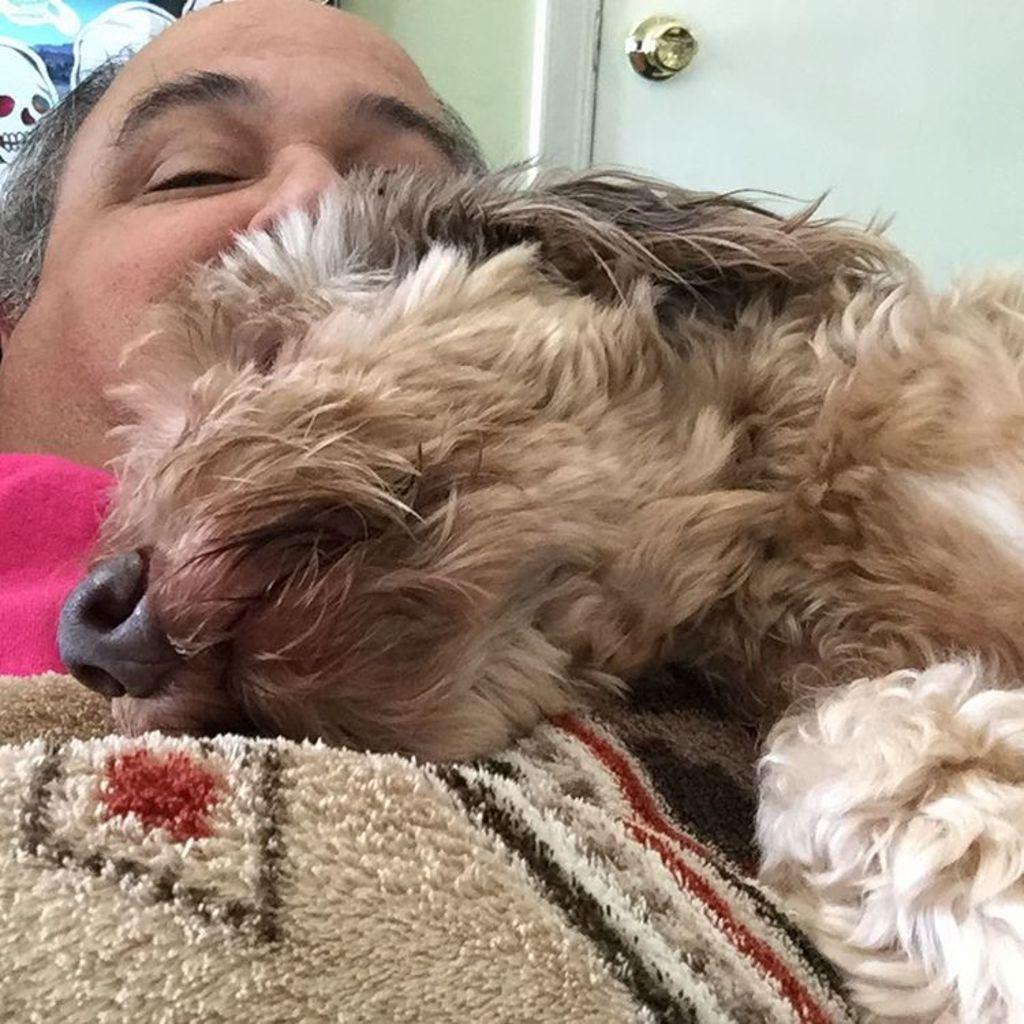Can you describe this image briefly? In this picture we can see a man and this is dog. On the background there is a door. 